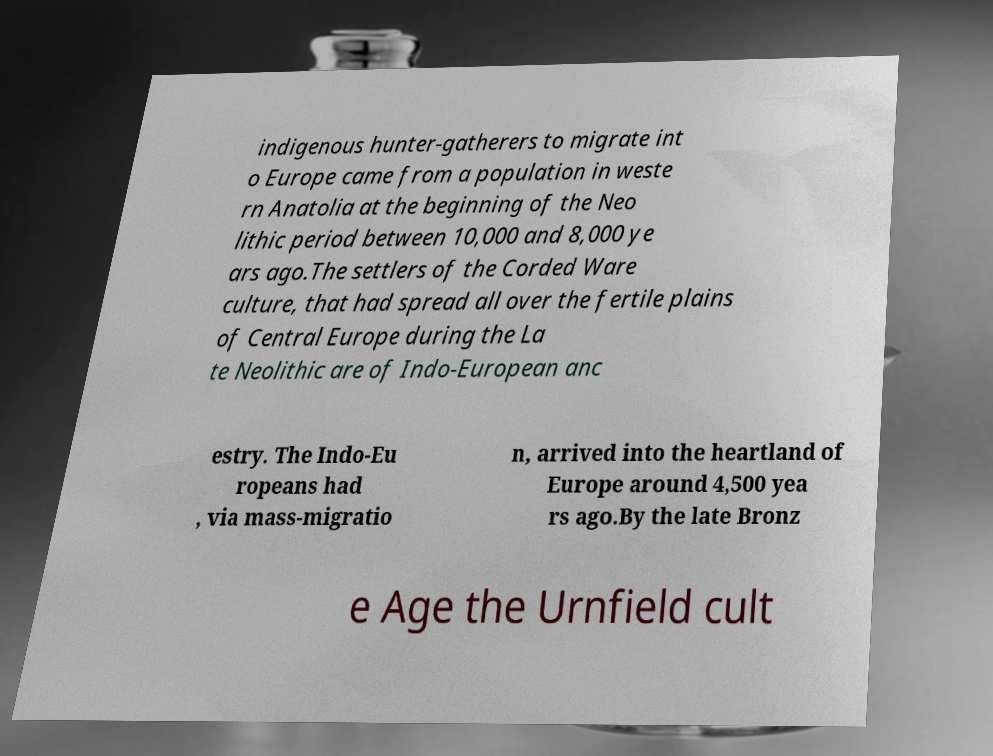Can you read and provide the text displayed in the image?This photo seems to have some interesting text. Can you extract and type it out for me? indigenous hunter-gatherers to migrate int o Europe came from a population in weste rn Anatolia at the beginning of the Neo lithic period between 10,000 and 8,000 ye ars ago.The settlers of the Corded Ware culture, that had spread all over the fertile plains of Central Europe during the La te Neolithic are of Indo-European anc estry. The Indo-Eu ropeans had , via mass-migratio n, arrived into the heartland of Europe around 4,500 yea rs ago.By the late Bronz e Age the Urnfield cult 